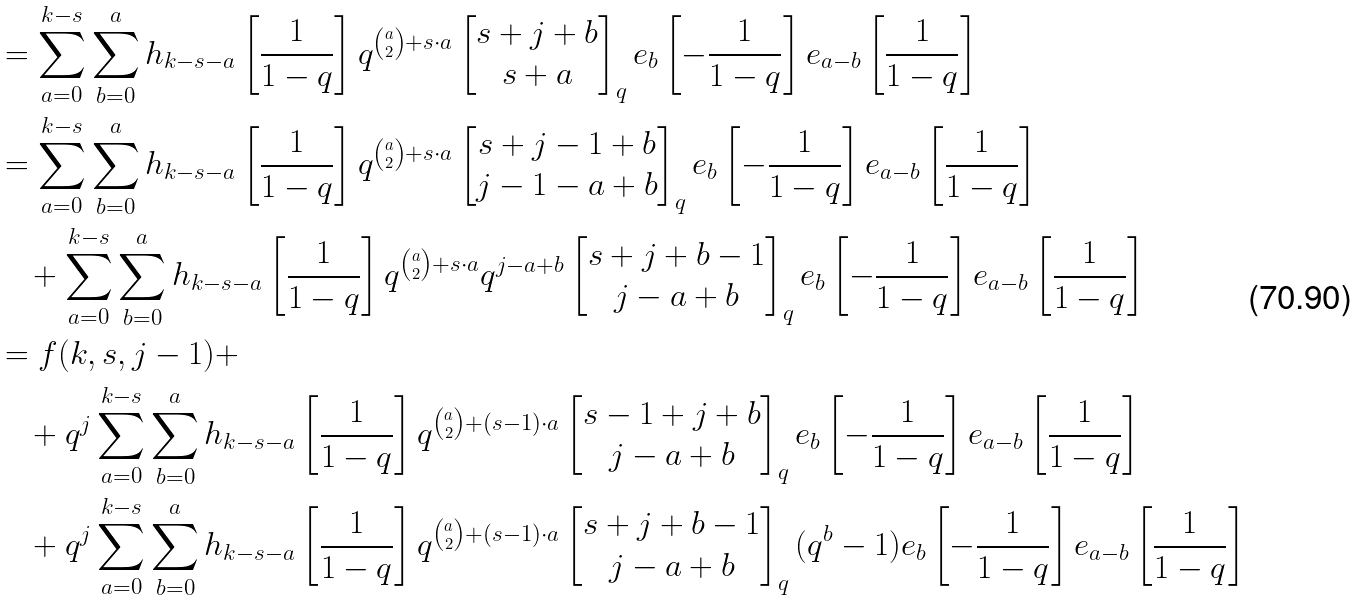<formula> <loc_0><loc_0><loc_500><loc_500>& = \sum _ { a = 0 } ^ { k - s } \sum _ { b = 0 } ^ { a } h _ { k - s - a } \left [ \frac { 1 } { 1 - q } \right ] q ^ { \binom { a } { 2 } + s \cdot a } \begin{bmatrix} s + j + b \\ s + a \end{bmatrix} _ { q } e _ { b } \left [ - \frac { 1 } { 1 - q } \right ] e _ { a - b } \left [ \frac { 1 } { 1 - q } \right ] \\ & = \sum _ { a = 0 } ^ { k - s } \sum _ { b = 0 } ^ { a } h _ { k - s - a } \left [ \frac { 1 } { 1 - q } \right ] q ^ { \binom { a } { 2 } + s \cdot a } \begin{bmatrix} s + j - 1 + b \\ j - 1 - a + b \end{bmatrix} _ { q } e _ { b } \left [ - \frac { 1 } { 1 - q } \right ] e _ { a - b } \left [ \frac { 1 } { 1 - q } \right ] \\ & \quad + \sum _ { a = 0 } ^ { k - s } \sum _ { b = 0 } ^ { a } h _ { k - s - a } \left [ \frac { 1 } { 1 - q } \right ] q ^ { \binom { a } { 2 } + s \cdot a } q ^ { j - a + b } \begin{bmatrix} s + j + b - 1 \\ j - a + b \end{bmatrix} _ { q } e _ { b } \left [ - \frac { 1 } { 1 - q } \right ] e _ { a - b } \left [ \frac { 1 } { 1 - q } \right ] \\ & = f ( k , s , j - 1 ) + \\ & \quad + q ^ { j } \sum _ { a = 0 } ^ { k - s } \sum _ { b = 0 } ^ { a } h _ { k - s - a } \left [ \frac { 1 } { 1 - q } \right ] q ^ { \binom { a } { 2 } + ( s - 1 ) \cdot a } \begin{bmatrix} s - 1 + j + b \\ j - a + b \end{bmatrix} _ { q } e _ { b } \left [ - \frac { 1 } { 1 - q } \right ] e _ { a - b } \left [ \frac { 1 } { 1 - q } \right ] \\ & \quad + q ^ { j } \sum _ { a = 0 } ^ { k - s } \sum _ { b = 0 } ^ { a } h _ { k - s - a } \left [ \frac { 1 } { 1 - q } \right ] q ^ { \binom { a } { 2 } + ( s - 1 ) \cdot a } \begin{bmatrix} s + j + b - 1 \\ j - a + b \end{bmatrix} _ { q } ( q ^ { b } - 1 ) e _ { b } \left [ - \frac { 1 } { 1 - q } \right ] e _ { a - b } \left [ \frac { 1 } { 1 - q } \right ]</formula> 